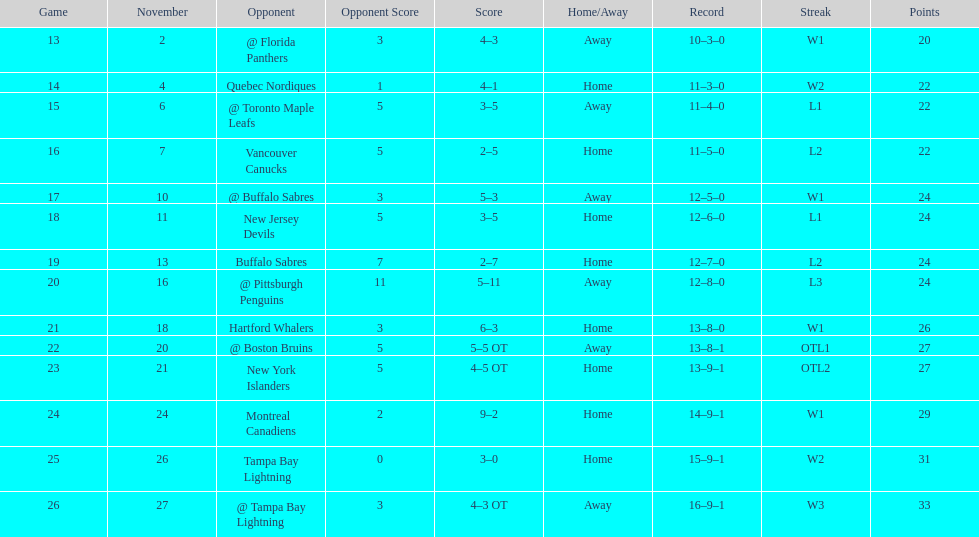Were the new jersey devils in last place according to the chart? No. 